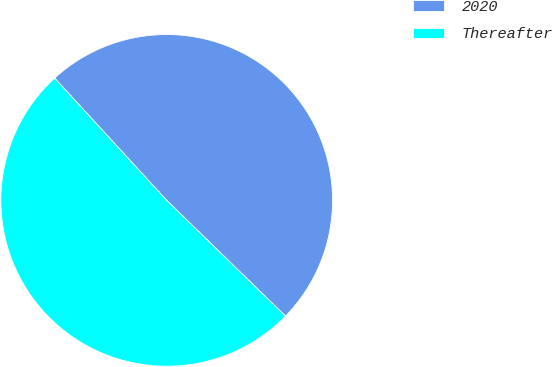<chart> <loc_0><loc_0><loc_500><loc_500><pie_chart><fcel>2020<fcel>Thereafter<nl><fcel>49.1%<fcel>50.9%<nl></chart> 